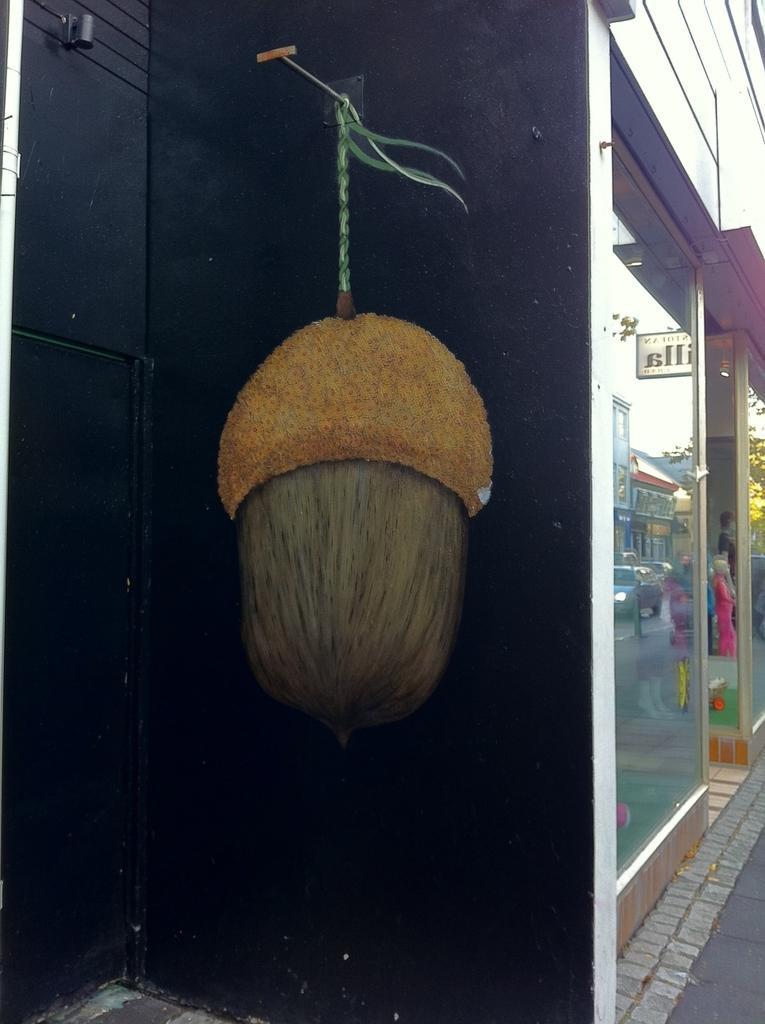In one or two sentences, can you explain what this image depicts? In this image there is a wall and we can see a wall painting on it. There is a store. 